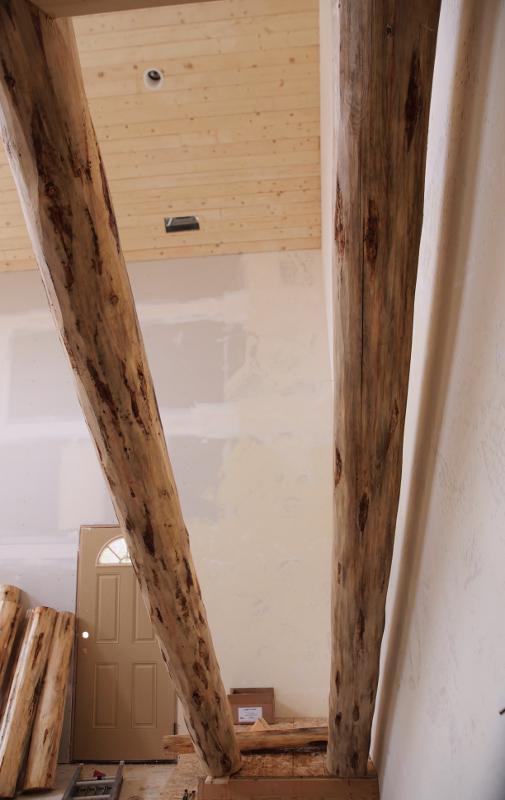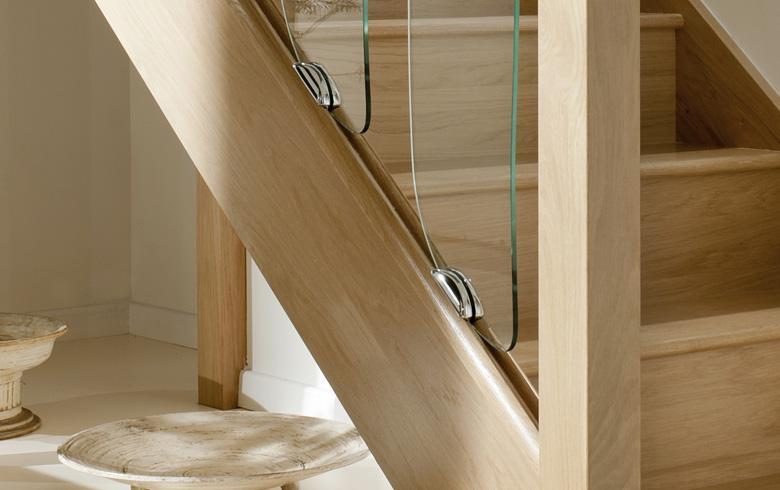The first image is the image on the left, the second image is the image on the right. Given the left and right images, does the statement "Each staircase has a banister." hold true? Answer yes or no. No. The first image is the image on the left, the second image is the image on the right. Considering the images on both sides, is "All of the staircases have vertical banisters for support." valid? Answer yes or no. No. 